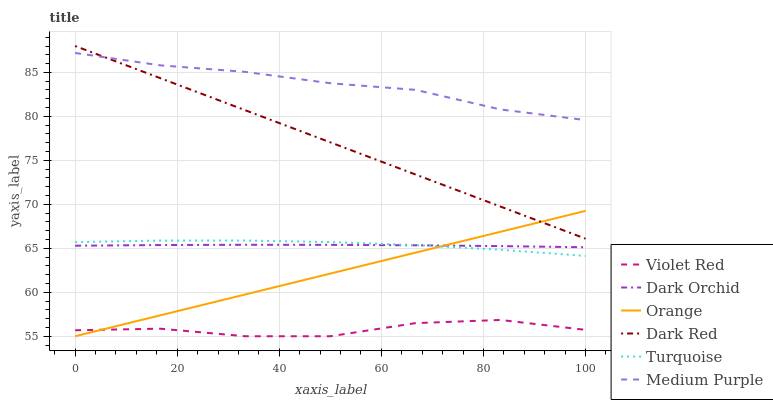Does Violet Red have the minimum area under the curve?
Answer yes or no. Yes. Does Medium Purple have the maximum area under the curve?
Answer yes or no. Yes. Does Dark Red have the minimum area under the curve?
Answer yes or no. No. Does Dark Red have the maximum area under the curve?
Answer yes or no. No. Is Dark Red the smoothest?
Answer yes or no. Yes. Is Violet Red the roughest?
Answer yes or no. Yes. Is Turquoise the smoothest?
Answer yes or no. No. Is Turquoise the roughest?
Answer yes or no. No. Does Violet Red have the lowest value?
Answer yes or no. Yes. Does Dark Red have the lowest value?
Answer yes or no. No. Does Dark Red have the highest value?
Answer yes or no. Yes. Does Turquoise have the highest value?
Answer yes or no. No. Is Violet Red less than Turquoise?
Answer yes or no. Yes. Is Medium Purple greater than Violet Red?
Answer yes or no. Yes. Does Dark Red intersect Medium Purple?
Answer yes or no. Yes. Is Dark Red less than Medium Purple?
Answer yes or no. No. Is Dark Red greater than Medium Purple?
Answer yes or no. No. Does Violet Red intersect Turquoise?
Answer yes or no. No. 